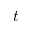<formula> <loc_0><loc_0><loc_500><loc_500>t</formula> 